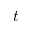<formula> <loc_0><loc_0><loc_500><loc_500>t</formula> 